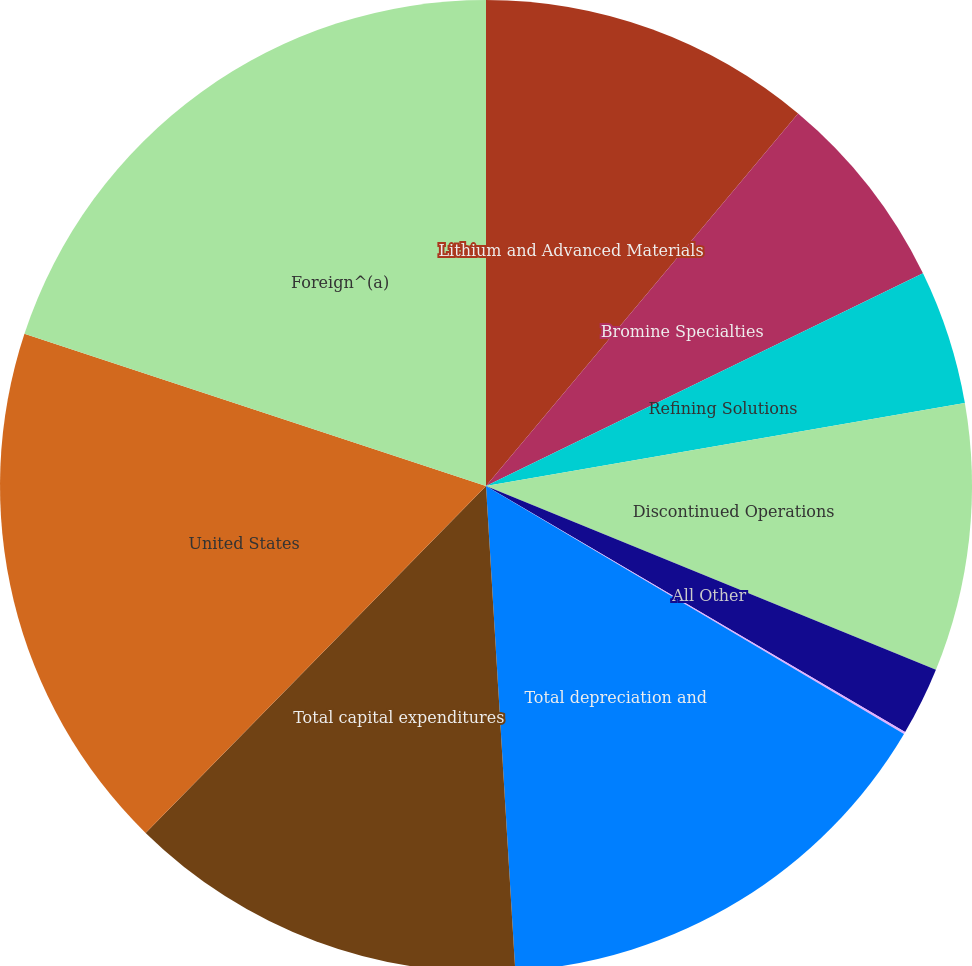Convert chart to OTSL. <chart><loc_0><loc_0><loc_500><loc_500><pie_chart><fcel>Lithium and Advanced Materials<fcel>Bromine Specialties<fcel>Refining Solutions<fcel>Discontinued Operations<fcel>All Other<fcel>Corporate<fcel>Total depreciation and<fcel>Total capital expenditures<fcel>United States<fcel>Foreign^(a)<nl><fcel>11.1%<fcel>6.69%<fcel>4.48%<fcel>8.9%<fcel>2.28%<fcel>0.07%<fcel>15.52%<fcel>13.31%<fcel>17.72%<fcel>19.93%<nl></chart> 